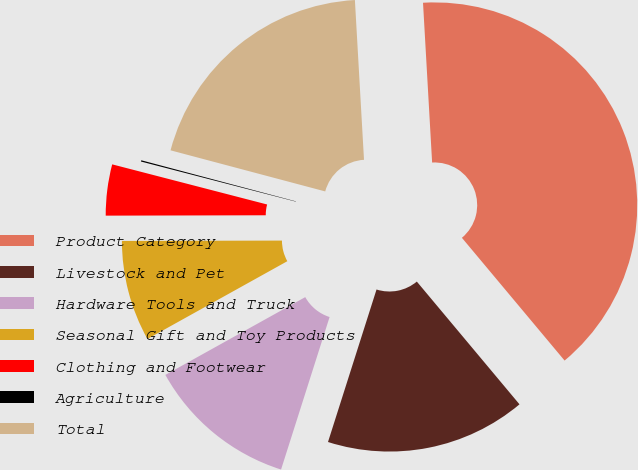Convert chart. <chart><loc_0><loc_0><loc_500><loc_500><pie_chart><fcel>Product Category<fcel>Livestock and Pet<fcel>Hardware Tools and Truck<fcel>Seasonal Gift and Toy Products<fcel>Clothing and Footwear<fcel>Agriculture<fcel>Total<nl><fcel>39.82%<fcel>15.99%<fcel>12.02%<fcel>8.04%<fcel>4.07%<fcel>0.1%<fcel>19.96%<nl></chart> 